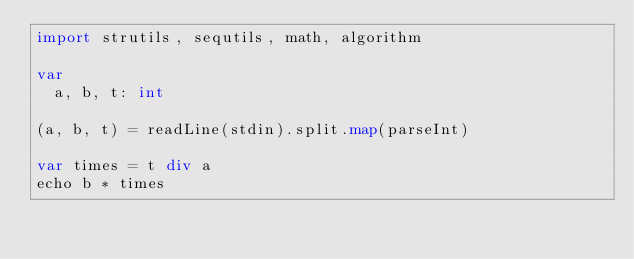Convert code to text. <code><loc_0><loc_0><loc_500><loc_500><_Nim_>import strutils, sequtils, math, algorithm

var
  a, b, t: int

(a, b, t) = readLine(stdin).split.map(parseInt)

var times = t div a
echo b * times
</code> 